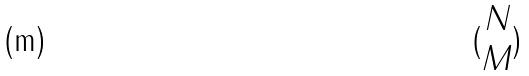Convert formula to latex. <formula><loc_0><loc_0><loc_500><loc_500>( \begin{matrix} N \\ M \end{matrix} )</formula> 